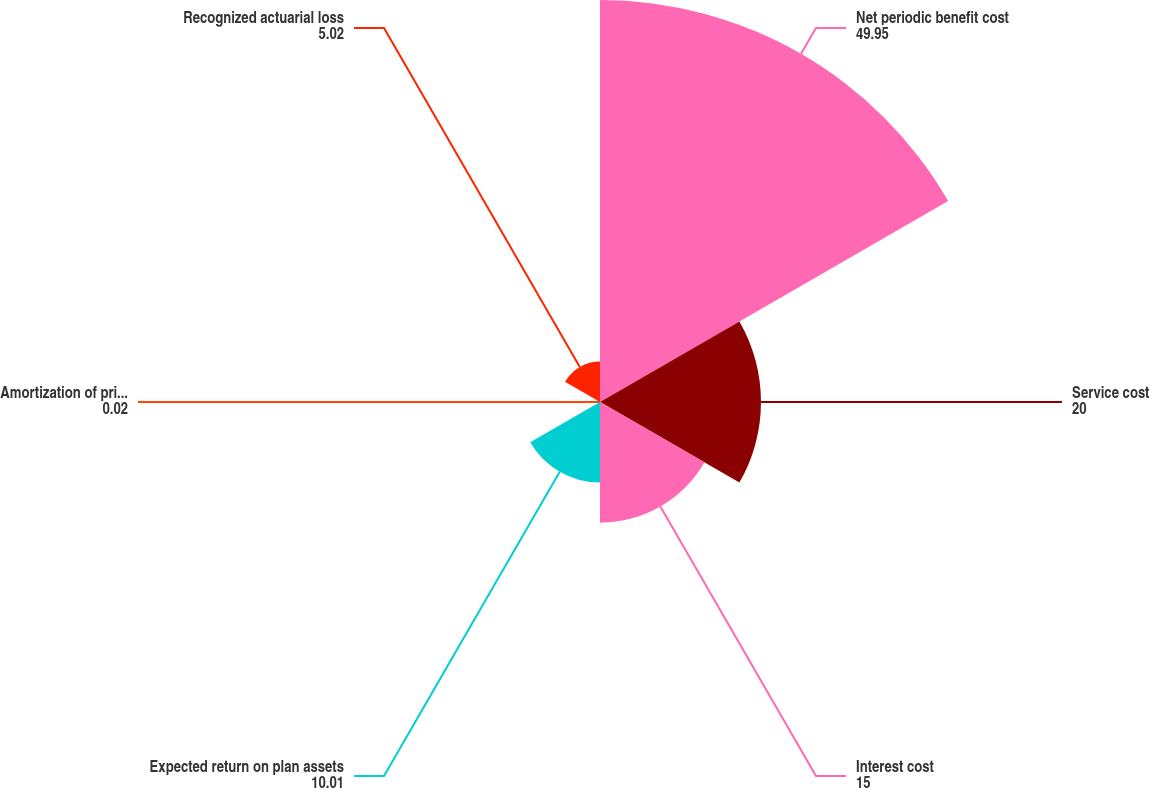Convert chart to OTSL. <chart><loc_0><loc_0><loc_500><loc_500><pie_chart><fcel>Net periodic benefit cost<fcel>Service cost<fcel>Interest cost<fcel>Expected return on plan assets<fcel>Amortization of prior service<fcel>Recognized actuarial loss<nl><fcel>49.95%<fcel>20.0%<fcel>15.0%<fcel>10.01%<fcel>0.02%<fcel>5.02%<nl></chart> 